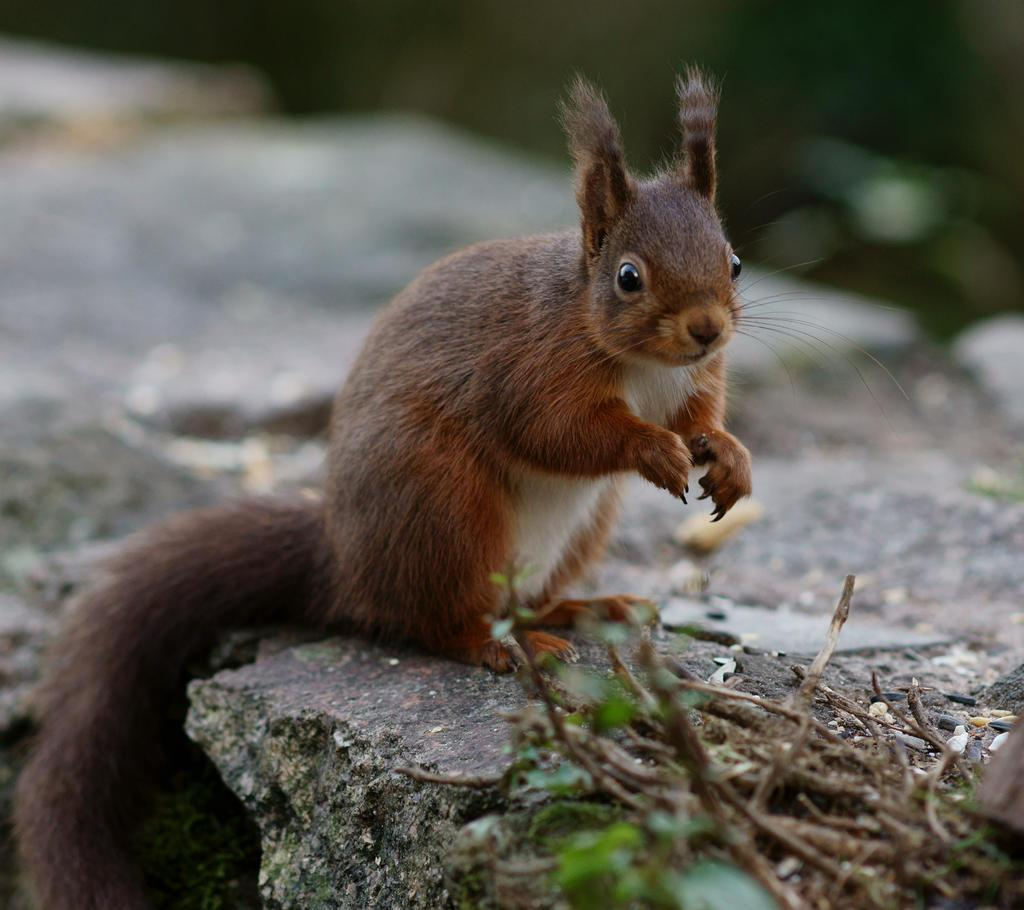What type of creature can be seen in the image? There is an animal in the image. Where is the animal located? The animal is sitting on rocks. What can be seen at the bottom of the image? There are plants visible at the bottom of the image. What type of hydrant can be seen in the image? There is no hydrant present in the image. Can you describe the stranger in the image? There is no stranger present in the image. 